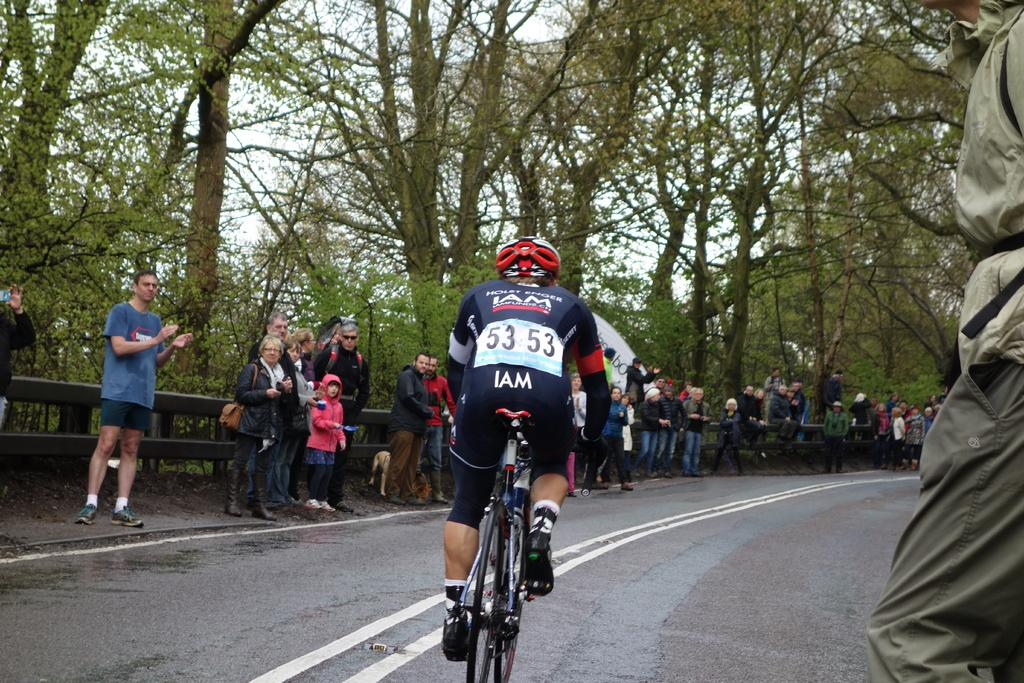What is happening in the foreground of the image? There is a group of people standing in the image. What activity is being performed by one of the people in the image? There is a person riding a bicycle on the road in the image. What can be seen in the background of the image? There are trees in the background of the image. Are there any other people visible in the image? Yes, there are additional people standing in the background of the image. What type of pen is being used to sign the agreement in the image? There is no agreement or pen present in the image; it features a group of people standing and a person riding a bicycle. Is there a river visible in the image? No, there is no river present in the image. 